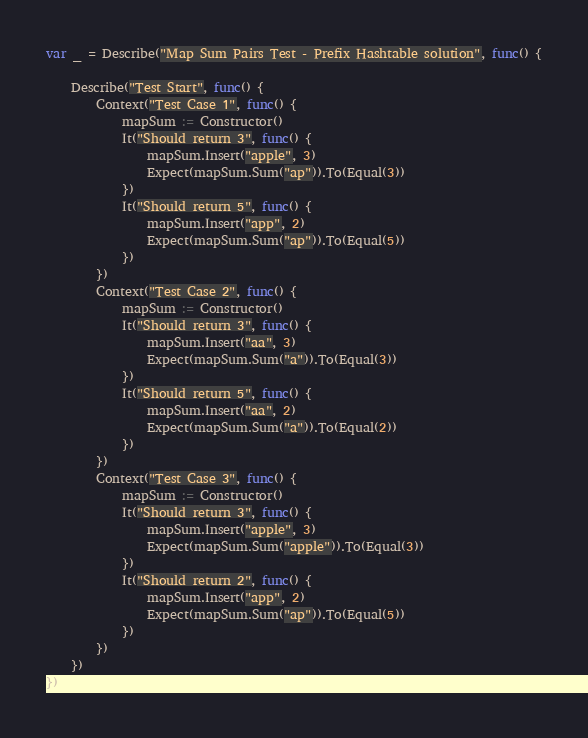Convert code to text. <code><loc_0><loc_0><loc_500><loc_500><_Go_>var _ = Describe("Map Sum Pairs Test - Prefix Hashtable solution", func() {

	Describe("Test Start", func() {
		Context("Test Case 1", func() {
			mapSum := Constructor()
			It("Should return 3", func() {
				mapSum.Insert("apple", 3)
				Expect(mapSum.Sum("ap")).To(Equal(3))
			})
			It("Should return 5", func() {
				mapSum.Insert("app", 2)
				Expect(mapSum.Sum("ap")).To(Equal(5))
			})
		})
		Context("Test Case 2", func() {
			mapSum := Constructor()
			It("Should return 3", func() {
				mapSum.Insert("aa", 3)
				Expect(mapSum.Sum("a")).To(Equal(3))
			})
			It("Should return 5", func() {
				mapSum.Insert("aa", 2)
				Expect(mapSum.Sum("a")).To(Equal(2))
			})
		})
		Context("Test Case 3", func() {
			mapSum := Constructor()
			It("Should return 3", func() {
				mapSum.Insert("apple", 3)
				Expect(mapSum.Sum("apple")).To(Equal(3))
			})
			It("Should return 2", func() {
				mapSum.Insert("app", 2)
				Expect(mapSum.Sum("ap")).To(Equal(5))
			})
		})
	})
})
</code> 